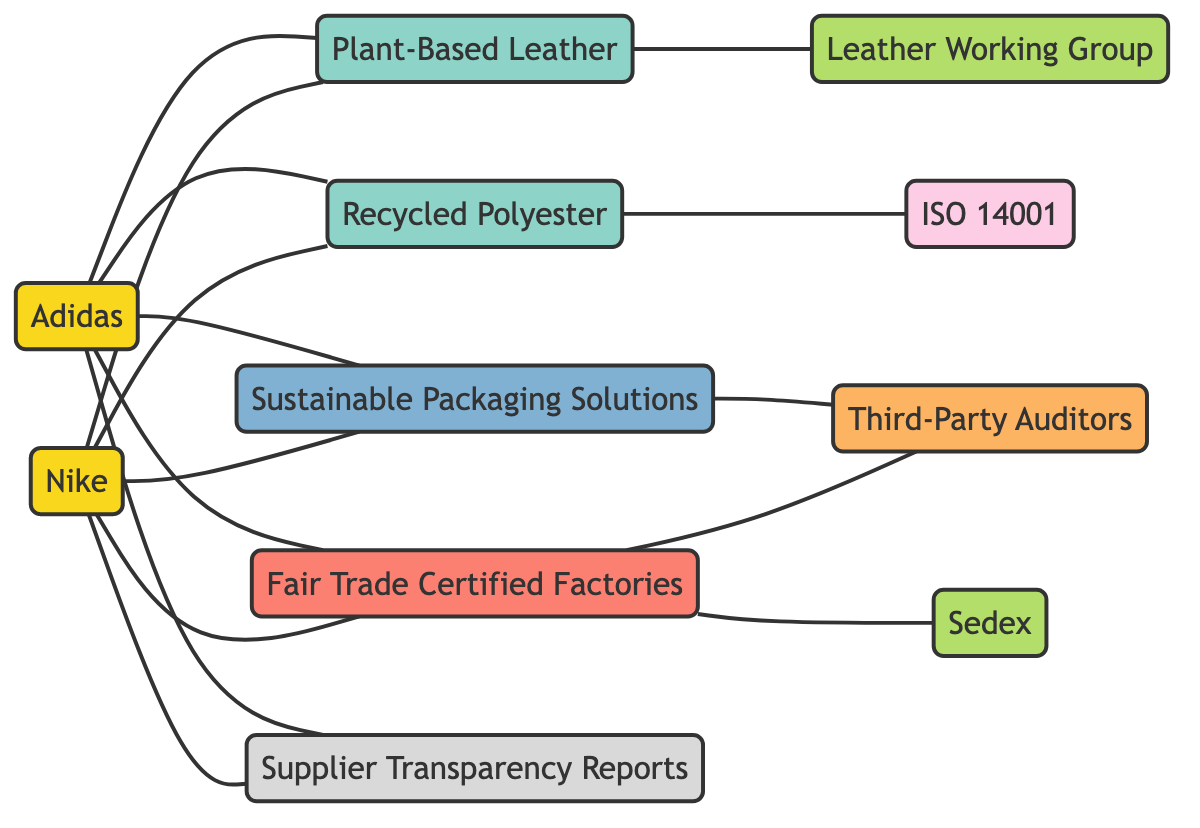What are the two brands represented in this diagram? The diagram includes two brands, Nike and Adidas, which can be identified as nodes labeled "Nike" and "Adidas."
Answer: Nike, Adidas How many materials are displayed in the supply chain? The diagram showcases three materials: Plant-Based Leather, Recycled Polyester, and the connections from both brands to these materials indicates their presence in the supply chain. Counting these nodes gives a total of three materials.
Answer: 3 Which standards organization is connected to Fair Trade Certified Factories? The diagram shows a connection between Fair Trade Certified Factories and Sedex, indicating that Sedex is the standards organization linked to these factories.
Answer: Sedex Do both brands have Supplier Transparency Reports? The diagram clearly illustrates that both Nike and Adidas are connected to Supplier Transparency Reports, demonstrating their commitment to transparency.
Answer: Yes Which certification is associated with Recycled Polyester? The diagram depicts a direct edge from Recycled Polyester to ISO 14001, establishing that ISO 14001 is the certification related to this material.
Answer: ISO 14001 Which materials are associated with Nike? By analyzing the connections from the node "Nike," we find that it is associated with Plant-Based Leather, Recycled Polyester, Fair Trade Certified Factories, and Sustainable Packaging Solutions.
Answer: Plant-Based Leather, Recycled Polyester, Fair Trade Certified Factories, Sustainable Packaging Solutions How many connections does Adidas have with materials and factories? The edges show that Adidas has four direct connections: two to materials (Plant-Based Leather, Recycled Polyester) and two to factories (Fair Trade Certified Factories, Sustainable Packaging Solutions), totaling four connections.
Answer: 4 Is there any overlap in the sourcing practices between Nike and Adidas? Both brands share the same sourced materials and factories since there are common connections to Plant-Based Leather, Recycled Polyester, Fair Trade Certified Factories, and Sustainable Packaging Solutions, indicating no differences in these sustainability practices.
Answer: Yes Which auditors are linked to Fair Trade Certified Factories? The diagram indicates a direct link from Fair Trade Certified Factories to Third-Party Auditors, establishing that Third-Party Auditors are the auditors connected to these factories.
Answer: Third-Party Auditors 